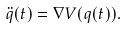Convert formula to latex. <formula><loc_0><loc_0><loc_500><loc_500>\ddot { q } ( t ) = \nabla V ( q ( t ) ) .</formula> 